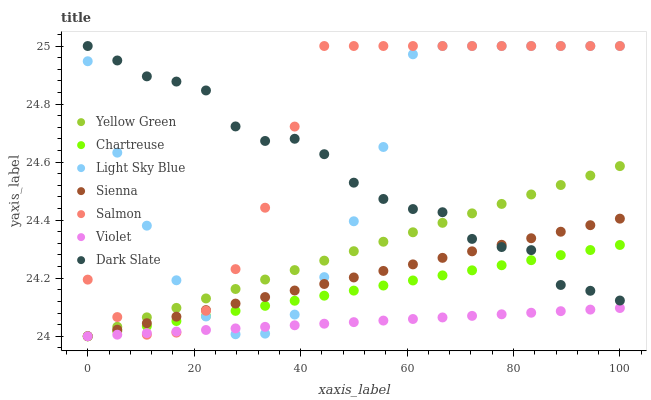Does Violet have the minimum area under the curve?
Answer yes or no. Yes. Does Salmon have the maximum area under the curve?
Answer yes or no. Yes. Does Sienna have the minimum area under the curve?
Answer yes or no. No. Does Sienna have the maximum area under the curve?
Answer yes or no. No. Is Chartreuse the smoothest?
Answer yes or no. Yes. Is Light Sky Blue the roughest?
Answer yes or no. Yes. Is Salmon the smoothest?
Answer yes or no. No. Is Salmon the roughest?
Answer yes or no. No. Does Yellow Green have the lowest value?
Answer yes or no. Yes. Does Salmon have the lowest value?
Answer yes or no. No. Does Light Sky Blue have the highest value?
Answer yes or no. Yes. Does Sienna have the highest value?
Answer yes or no. No. Is Violet less than Dark Slate?
Answer yes or no. Yes. Is Dark Slate greater than Violet?
Answer yes or no. Yes. Does Dark Slate intersect Salmon?
Answer yes or no. Yes. Is Dark Slate less than Salmon?
Answer yes or no. No. Is Dark Slate greater than Salmon?
Answer yes or no. No. Does Violet intersect Dark Slate?
Answer yes or no. No. 